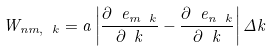Convert formula to latex. <formula><loc_0><loc_0><loc_500><loc_500>W _ { n m , \ k } = a \left | \frac { \partial \ e _ { m \ k } } { \partial \ k } - \frac { \partial \ e _ { n \ k } } { \partial \ k } \right | \Delta k</formula> 